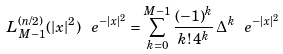<formula> <loc_0><loc_0><loc_500><loc_500>L _ { M - 1 } ^ { ( n / 2 ) } ( | x | ^ { 2 } ) \, \ e ^ { - | x | ^ { 2 } } = \sum _ { k = 0 } ^ { M - 1 } \frac { ( - 1 ) ^ { k } } { k ! \, 4 ^ { k } } \, \Delta ^ { k } \ e ^ { - | x | ^ { 2 } }</formula> 